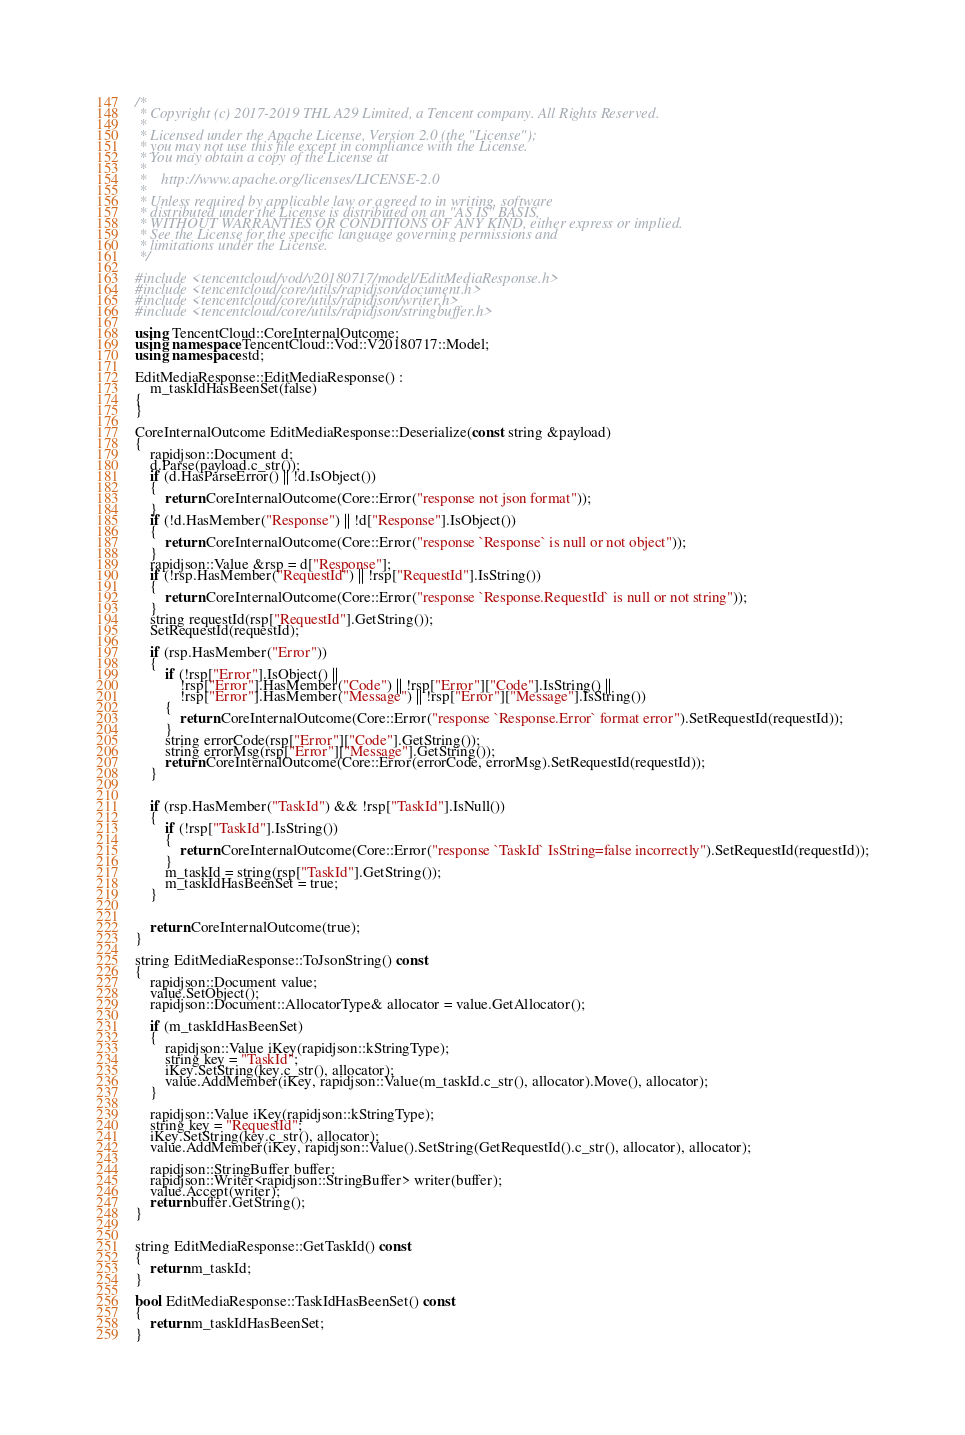<code> <loc_0><loc_0><loc_500><loc_500><_C++_>/*
 * Copyright (c) 2017-2019 THL A29 Limited, a Tencent company. All Rights Reserved.
 *
 * Licensed under the Apache License, Version 2.0 (the "License");
 * you may not use this file except in compliance with the License.
 * You may obtain a copy of the License at
 *
 *    http://www.apache.org/licenses/LICENSE-2.0
 *
 * Unless required by applicable law or agreed to in writing, software
 * distributed under the License is distributed on an "AS IS" BASIS,
 * WITHOUT WARRANTIES OR CONDITIONS OF ANY KIND, either express or implied.
 * See the License for the specific language governing permissions and
 * limitations under the License.
 */

#include <tencentcloud/vod/v20180717/model/EditMediaResponse.h>
#include <tencentcloud/core/utils/rapidjson/document.h>
#include <tencentcloud/core/utils/rapidjson/writer.h>
#include <tencentcloud/core/utils/rapidjson/stringbuffer.h>

using TencentCloud::CoreInternalOutcome;
using namespace TencentCloud::Vod::V20180717::Model;
using namespace std;

EditMediaResponse::EditMediaResponse() :
    m_taskIdHasBeenSet(false)
{
}

CoreInternalOutcome EditMediaResponse::Deserialize(const string &payload)
{
    rapidjson::Document d;
    d.Parse(payload.c_str());
    if (d.HasParseError() || !d.IsObject())
    {
        return CoreInternalOutcome(Core::Error("response not json format"));
    }
    if (!d.HasMember("Response") || !d["Response"].IsObject())
    {
        return CoreInternalOutcome(Core::Error("response `Response` is null or not object"));
    }
    rapidjson::Value &rsp = d["Response"];
    if (!rsp.HasMember("RequestId") || !rsp["RequestId"].IsString())
    {
        return CoreInternalOutcome(Core::Error("response `Response.RequestId` is null or not string"));
    }
    string requestId(rsp["RequestId"].GetString());
    SetRequestId(requestId);

    if (rsp.HasMember("Error"))
    {
        if (!rsp["Error"].IsObject() ||
            !rsp["Error"].HasMember("Code") || !rsp["Error"]["Code"].IsString() ||
            !rsp["Error"].HasMember("Message") || !rsp["Error"]["Message"].IsString())
        {
            return CoreInternalOutcome(Core::Error("response `Response.Error` format error").SetRequestId(requestId));
        }
        string errorCode(rsp["Error"]["Code"].GetString());
        string errorMsg(rsp["Error"]["Message"].GetString());
        return CoreInternalOutcome(Core::Error(errorCode, errorMsg).SetRequestId(requestId));
    }


    if (rsp.HasMember("TaskId") && !rsp["TaskId"].IsNull())
    {
        if (!rsp["TaskId"].IsString())
        {
            return CoreInternalOutcome(Core::Error("response `TaskId` IsString=false incorrectly").SetRequestId(requestId));
        }
        m_taskId = string(rsp["TaskId"].GetString());
        m_taskIdHasBeenSet = true;
    }


    return CoreInternalOutcome(true);
}

string EditMediaResponse::ToJsonString() const
{
    rapidjson::Document value;
    value.SetObject();
    rapidjson::Document::AllocatorType& allocator = value.GetAllocator();

    if (m_taskIdHasBeenSet)
    {
        rapidjson::Value iKey(rapidjson::kStringType);
        string key = "TaskId";
        iKey.SetString(key.c_str(), allocator);
        value.AddMember(iKey, rapidjson::Value(m_taskId.c_str(), allocator).Move(), allocator);
    }

    rapidjson::Value iKey(rapidjson::kStringType);
    string key = "RequestId";
    iKey.SetString(key.c_str(), allocator);
    value.AddMember(iKey, rapidjson::Value().SetString(GetRequestId().c_str(), allocator), allocator);
    
    rapidjson::StringBuffer buffer;
    rapidjson::Writer<rapidjson::StringBuffer> writer(buffer);
    value.Accept(writer);
    return buffer.GetString();
}


string EditMediaResponse::GetTaskId() const
{
    return m_taskId;
}

bool EditMediaResponse::TaskIdHasBeenSet() const
{
    return m_taskIdHasBeenSet;
}


</code> 